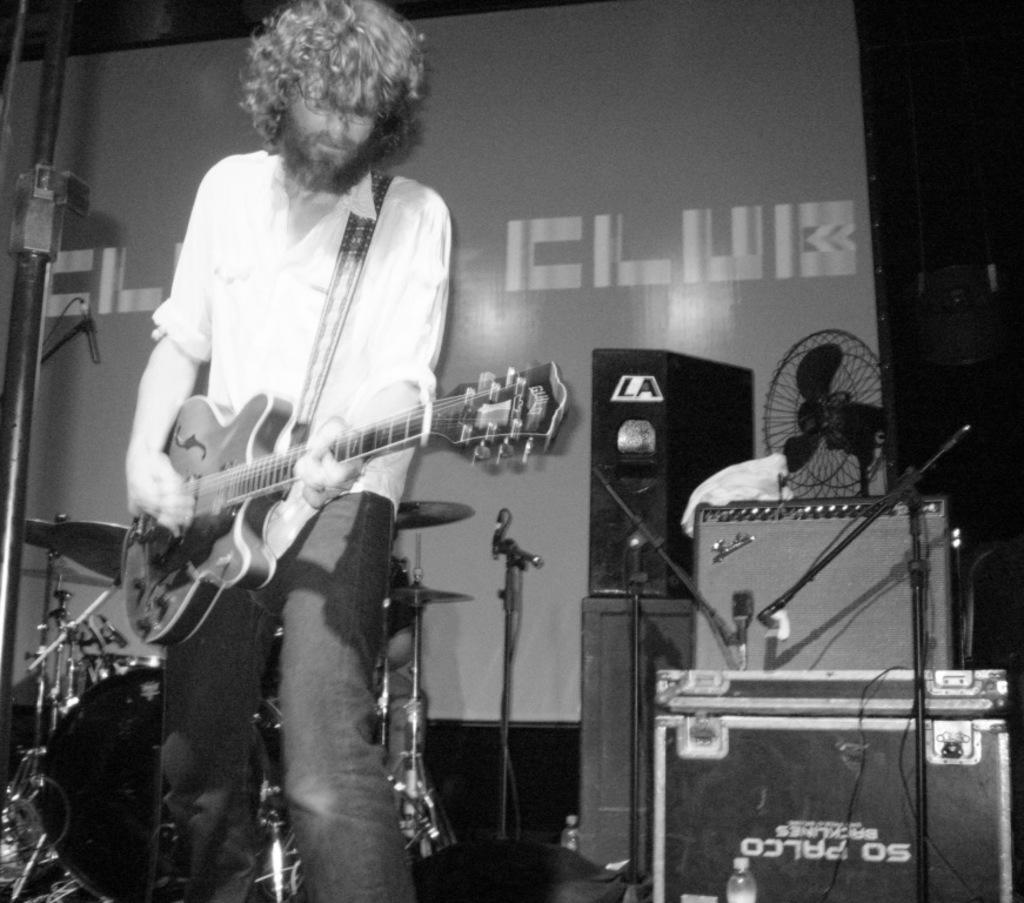Can you describe this image briefly? He is standing and his playing a musical instruments. 